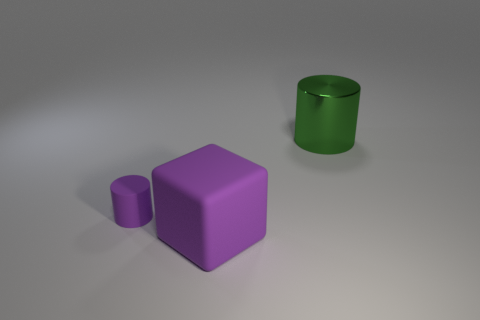Add 2 big yellow shiny blocks. How many objects exist? 5 Subtract all cubes. How many objects are left? 2 Add 1 purple matte objects. How many purple matte objects are left? 3 Add 2 big red objects. How many big red objects exist? 2 Subtract 0 purple spheres. How many objects are left? 3 Subtract all green shiny objects. Subtract all large rubber blocks. How many objects are left? 1 